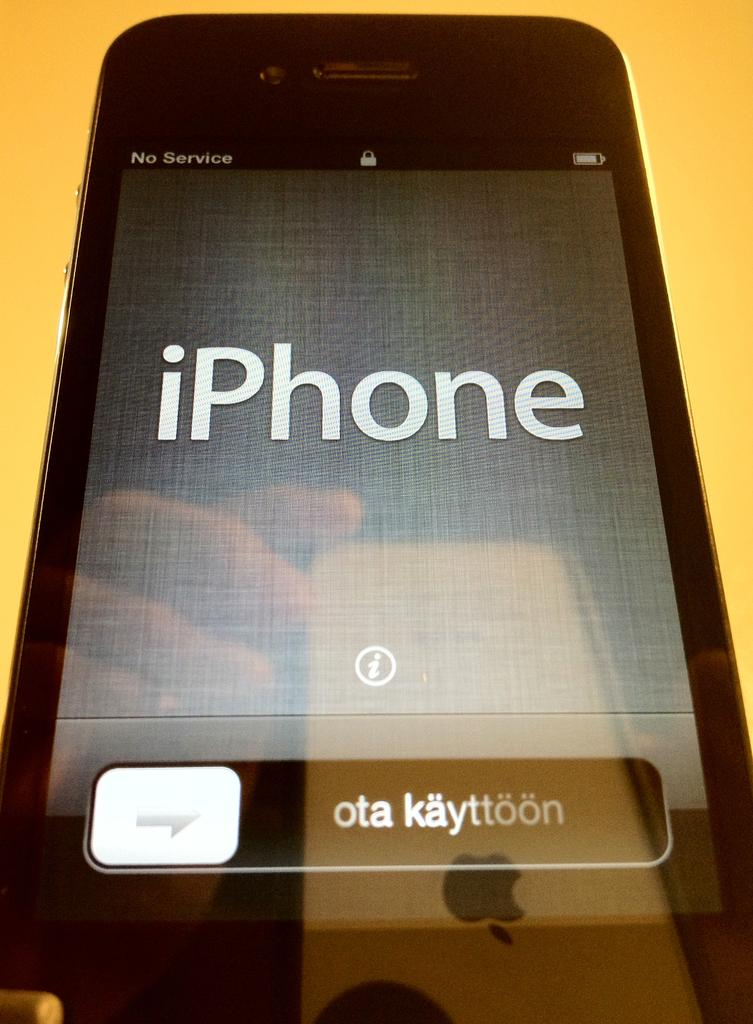Provide a one-sentence caption for the provided image. Screen of a black phone that says "iPhone" in it. 